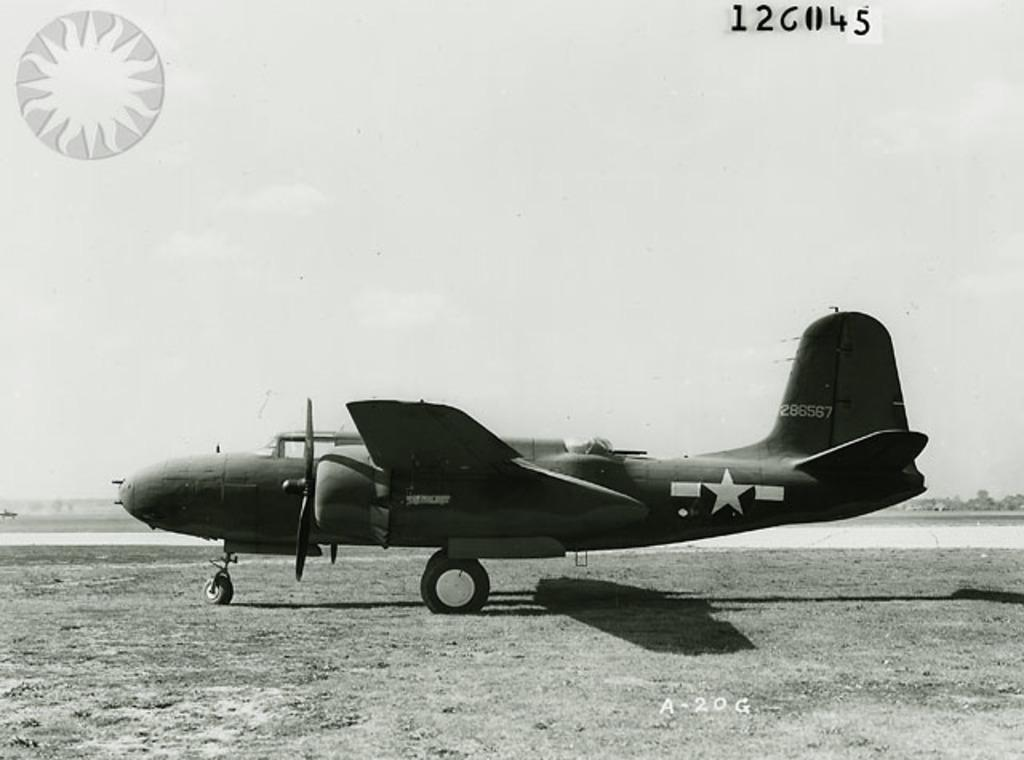<image>
Render a clear and concise summary of the photo. A bomber plane is on a grass runway and says 286567 on the tail. 